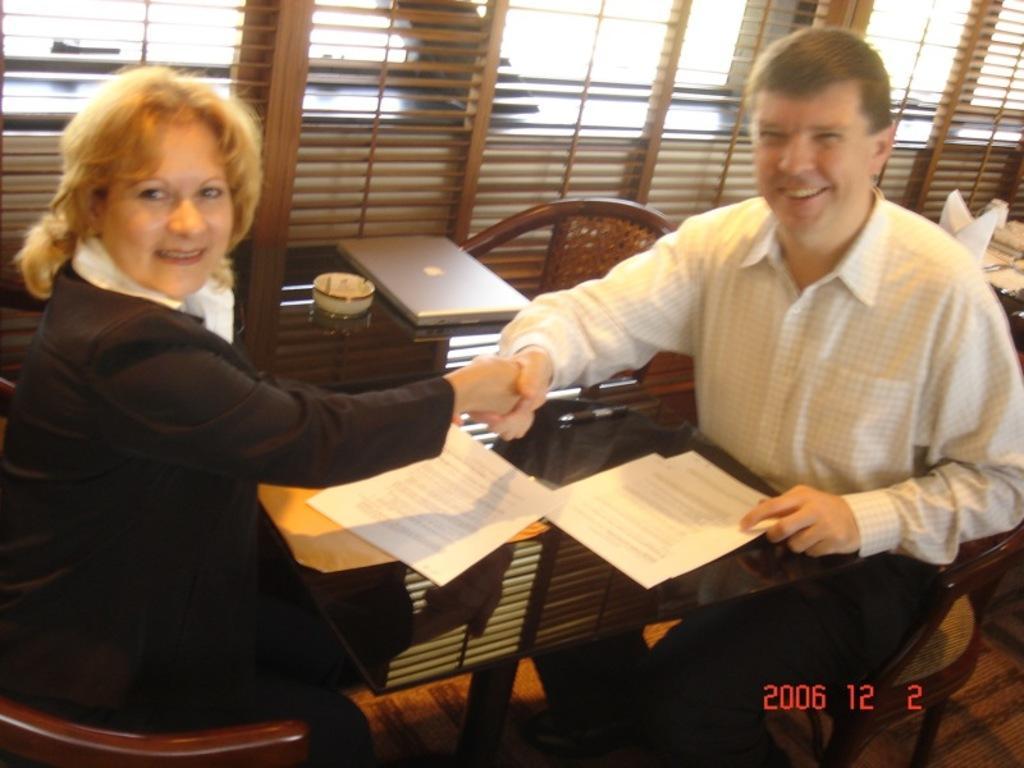How would you summarize this image in a sentence or two? In this image we can see two persons sitting on the chairs and a table is placed in front of them. On the table we can see a bowel, laptop and papers. In the background there are blinds, paper napkins and sky. 